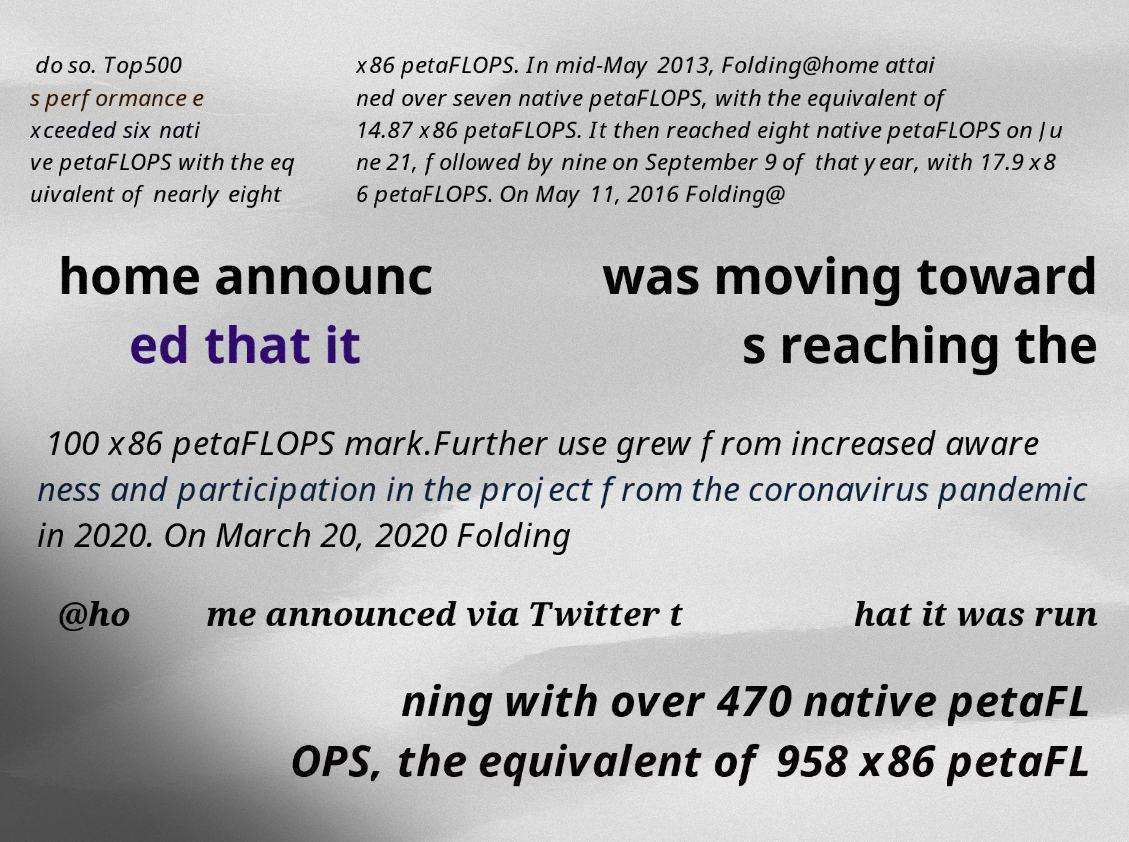Please identify and transcribe the text found in this image. do so. Top500 s performance e xceeded six nati ve petaFLOPS with the eq uivalent of nearly eight x86 petaFLOPS. In mid-May 2013, Folding@home attai ned over seven native petaFLOPS, with the equivalent of 14.87 x86 petaFLOPS. It then reached eight native petaFLOPS on Ju ne 21, followed by nine on September 9 of that year, with 17.9 x8 6 petaFLOPS. On May 11, 2016 Folding@ home announc ed that it was moving toward s reaching the 100 x86 petaFLOPS mark.Further use grew from increased aware ness and participation in the project from the coronavirus pandemic in 2020. On March 20, 2020 Folding @ho me announced via Twitter t hat it was run ning with over 470 native petaFL OPS, the equivalent of 958 x86 petaFL 